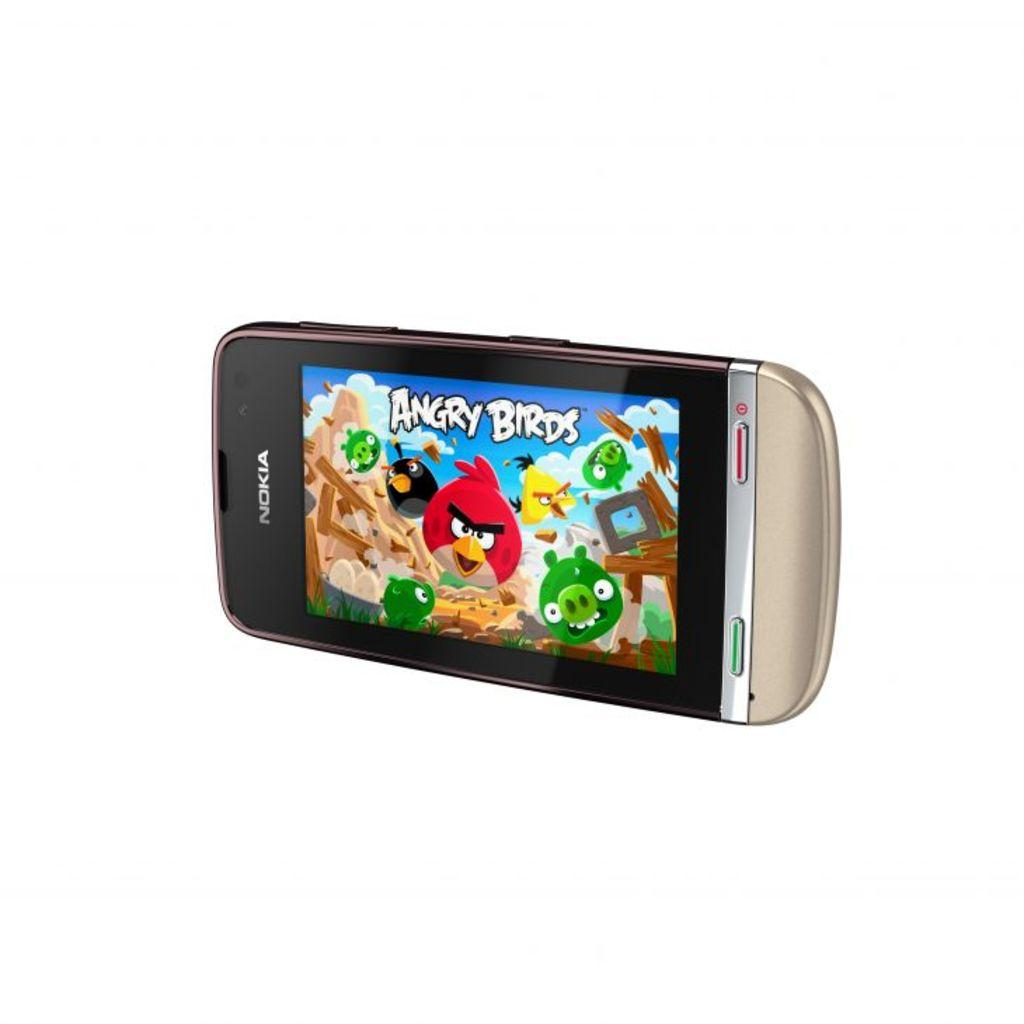Provide a one-sentence caption for the provided image. A Nokia brand phone with the game Angry Birds on the screen. 